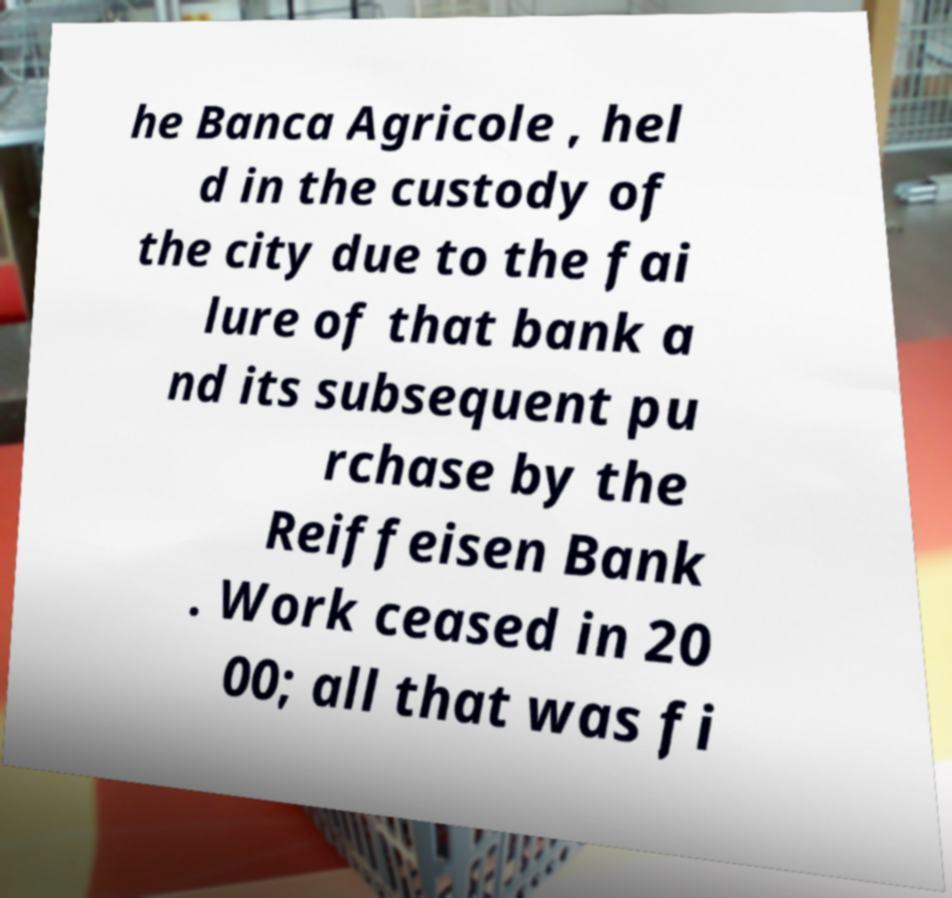Can you read and provide the text displayed in the image?This photo seems to have some interesting text. Can you extract and type it out for me? he Banca Agricole , hel d in the custody of the city due to the fai lure of that bank a nd its subsequent pu rchase by the Reiffeisen Bank . Work ceased in 20 00; all that was fi 